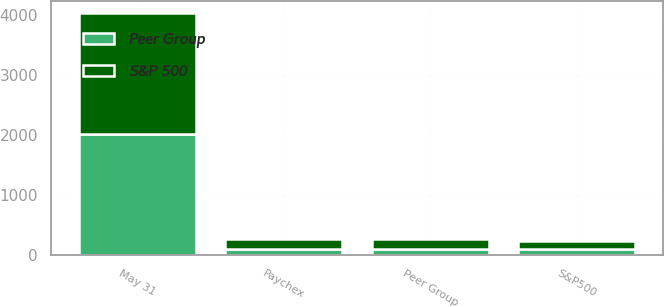Convert chart. <chart><loc_0><loc_0><loc_500><loc_500><stacked_bar_chart><ecel><fcel>May 31<fcel>Paychex<fcel>S&P500<fcel>Peer Group<nl><fcel>Peer Group<fcel>2013<fcel>100<fcel>100<fcel>100<nl><fcel>S&P 500<fcel>2016<fcel>161.2<fcel>136.98<fcel>167.3<nl></chart> 